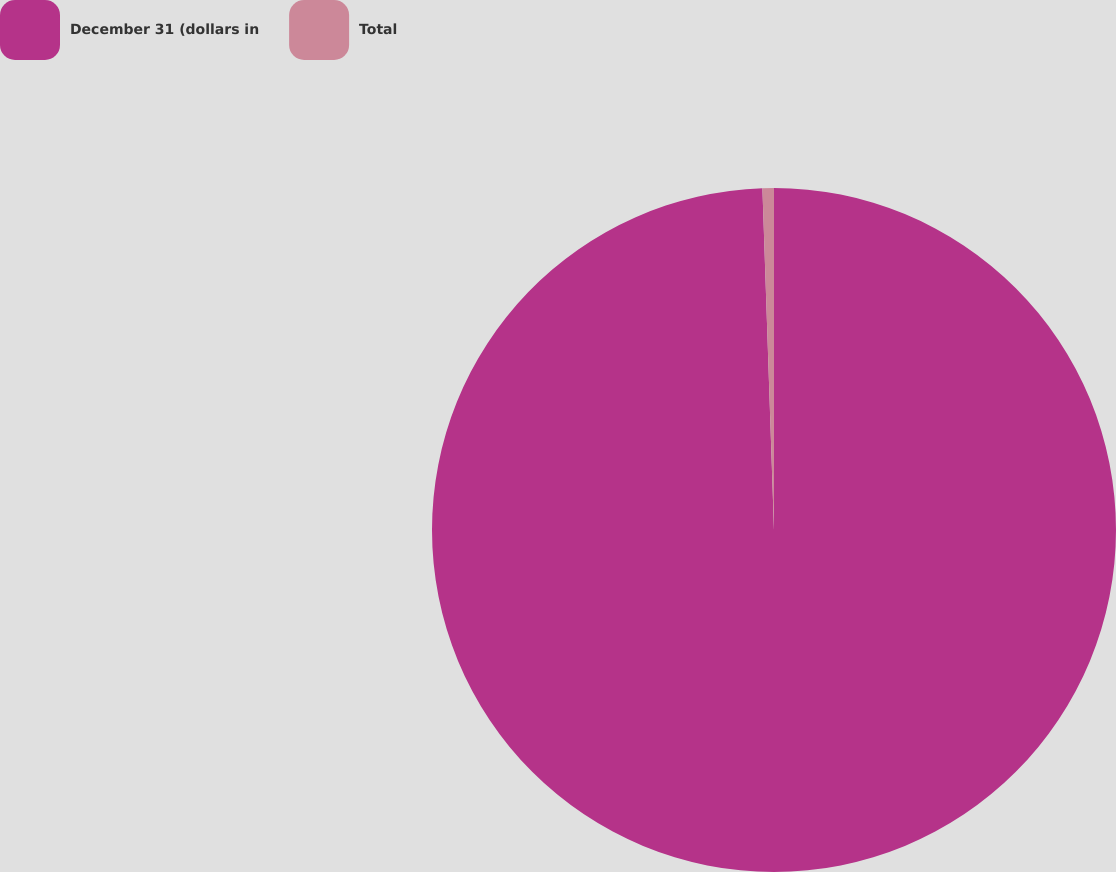Convert chart. <chart><loc_0><loc_0><loc_500><loc_500><pie_chart><fcel>December 31 (dollars in<fcel>Total<nl><fcel>99.46%<fcel>0.54%<nl></chart> 